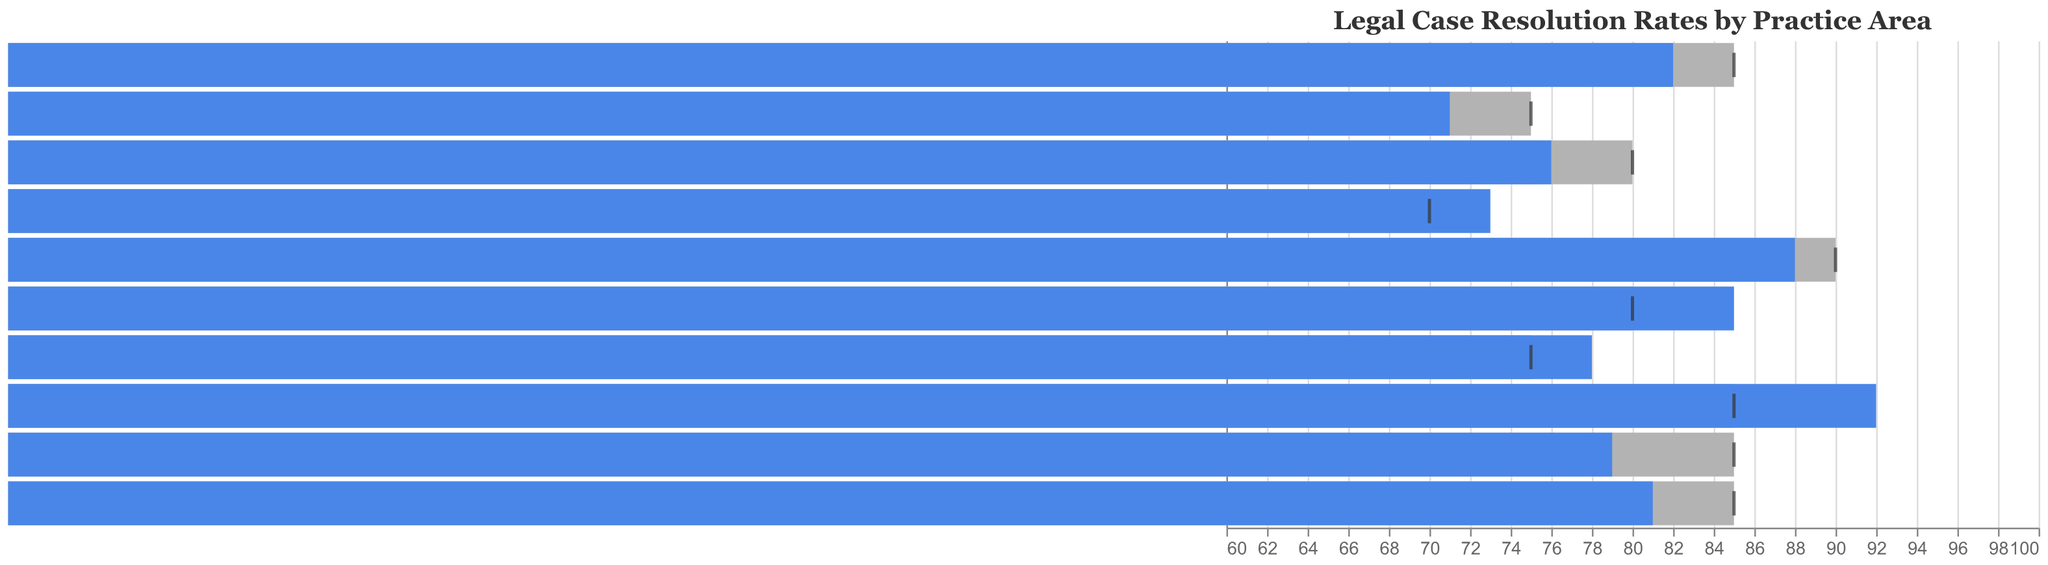What is the title of the chart? The title of the chart is displayed at the top and reads, "Legal Case Resolution Rates by Practice Area".
Answer: Legal Case Resolution Rates by Practice Area Which practice area has the highest actual resolution rate? By observing the blue bars in the chart, the longest bar represents the highest actual resolution rate, which is in the practice area of Personal Injury.
Answer: Personal Injury How many practice areas met or exceeded their target resolution rate? Compare the length of the blue bars (actual resolution rate) with the marks (target resolution rate). Intellectual Property, Immigration Law, Personal Injury, and Environmental Law meet or exceed their targets.
Answer: 4 What is the difference between the actual resolution rate and the target rate for Criminal Defense? For Criminal Defense, the actual resolution rate is 71% and the target rate is 75%. The difference is calculated as 75 - 71.
Answer: 4% Which practice area fell the furthest from meeting its target resolution rate? By looking for the largest negative gap between the blue bars (actual resolution rate) and the ticks (target rates), Real Estate Law has the biggest gap as it falls from 79% actual to 85% target.
Answer: Real Estate Law What is the average benchmark rate across all practice areas? The benchmark rates are 80, 70, 85, 72, 78, 82, 75, 88, 80, 68. Calculate the average by summing these and dividing by the number of practice areas: (80+70+85+72+78+82+75+88+80+68)/10.
Answer: 77.8% Which practice area has the smallest difference between its actual resolution rate and its benchmark rate? Calculate the differences for all practice areas between their actual rates and benchmark rates, then determine the smallest difference. Immigration Law has a difference of 85 - 78 = 7%.
Answer: Immigration Law Did Environmental Law exceed its benchmark rate? Compare the actual resolution rate of Environmental Law (73%) with its benchmark rate (68%). Since 73 > 68, it exceeded its benchmark rate.
Answer: Yes What's the range of the target resolution rates among all practice areas? Identify the highest and lowest target rates from the data: 90% (Family Law) and 70% (Environmental Law). The range is 90 - 70.
Answer: 20% 